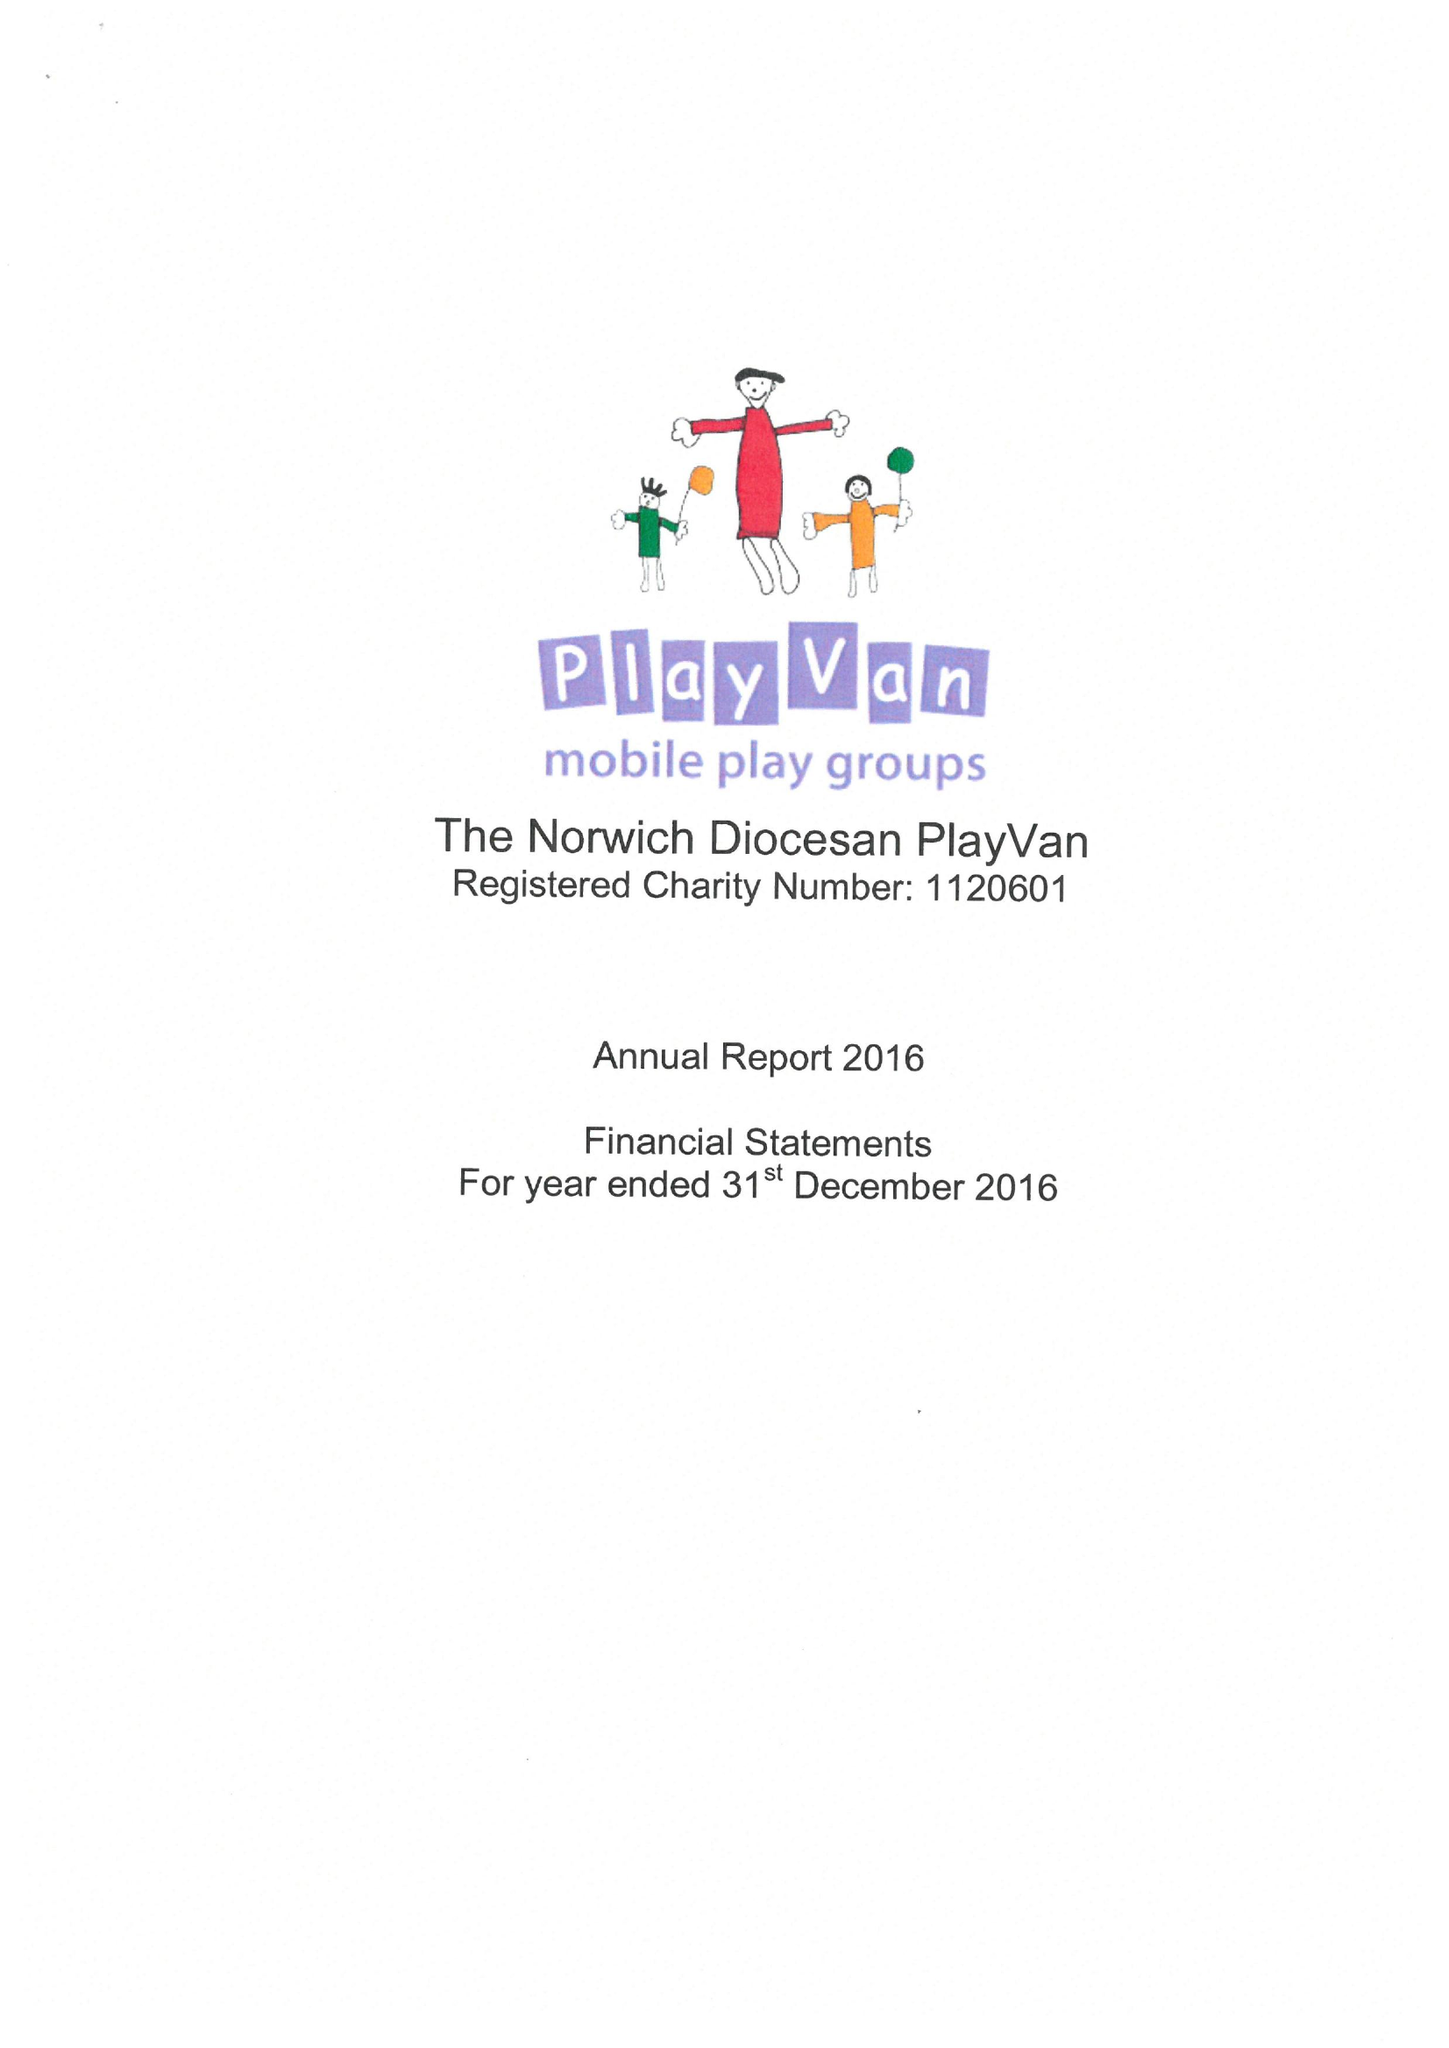What is the value for the address__postcode?
Answer the question using a single word or phrase. NR9 5ES 